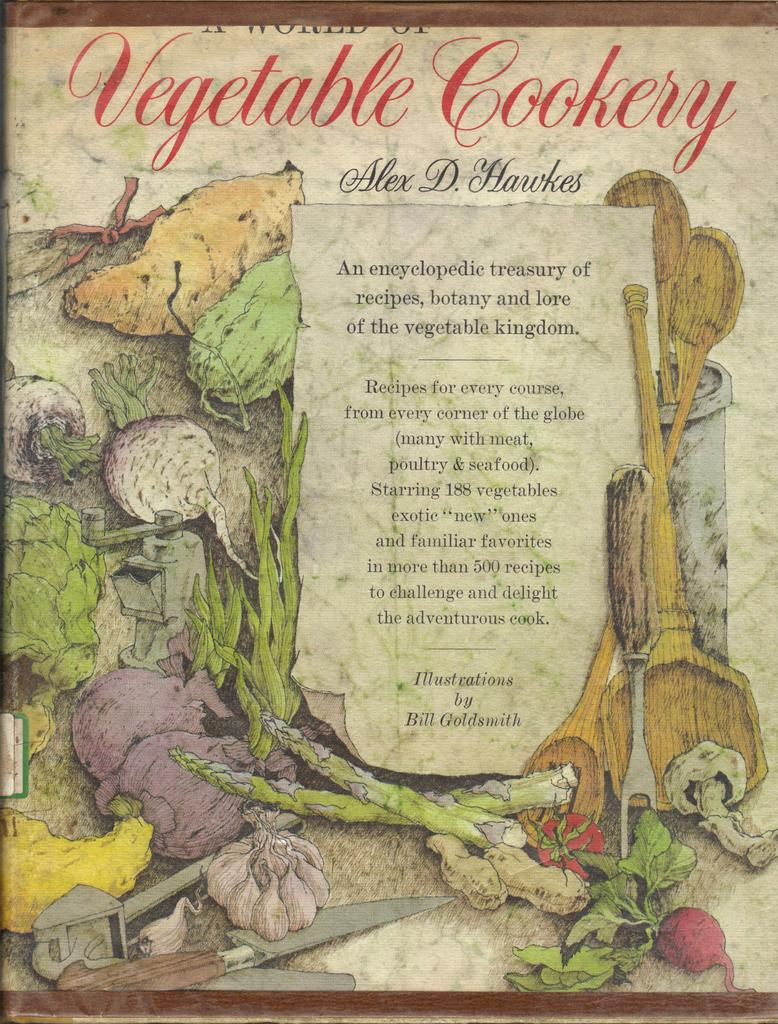What is the main subject of the image? The main subject of the image is a vegetable cookery poster. Can you describe the poster in more detail? Unfortunately, the provided facts do not offer any additional details about the poster. What types of toys are displayed on the poster? There is no mention of toys in the image or the provided fact. The image only features a vegetable cookery poster. 